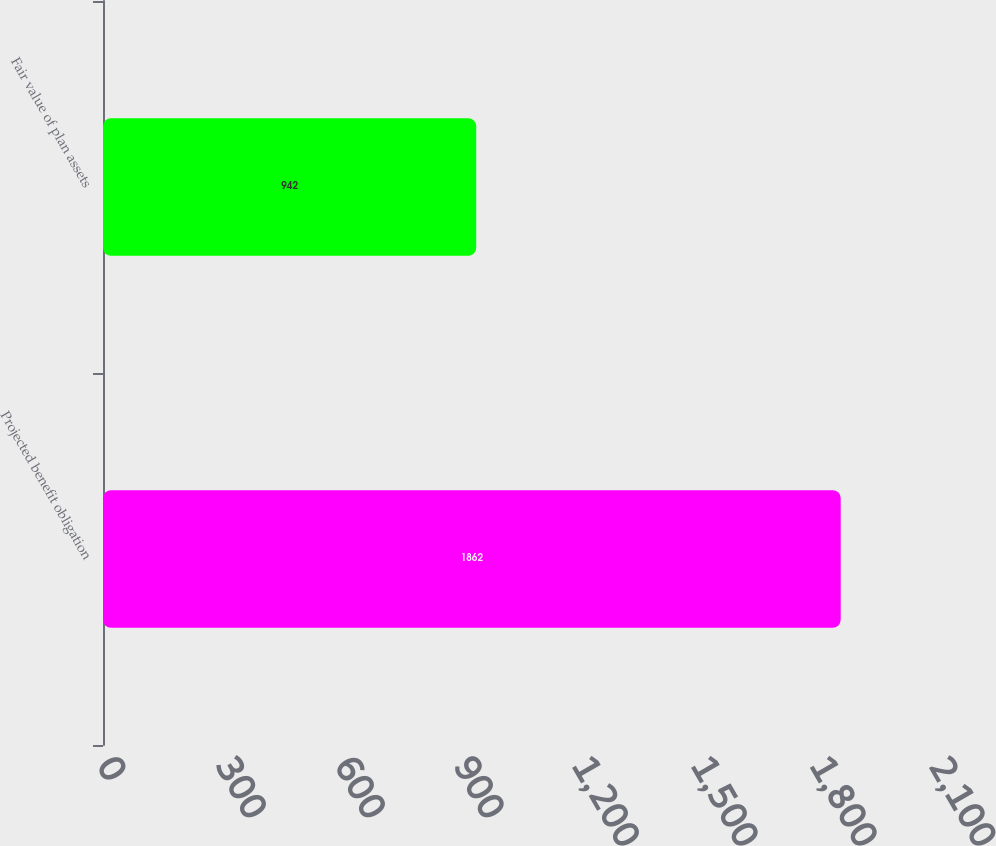Convert chart to OTSL. <chart><loc_0><loc_0><loc_500><loc_500><bar_chart><fcel>Projected benefit obligation<fcel>Fair value of plan assets<nl><fcel>1862<fcel>942<nl></chart> 